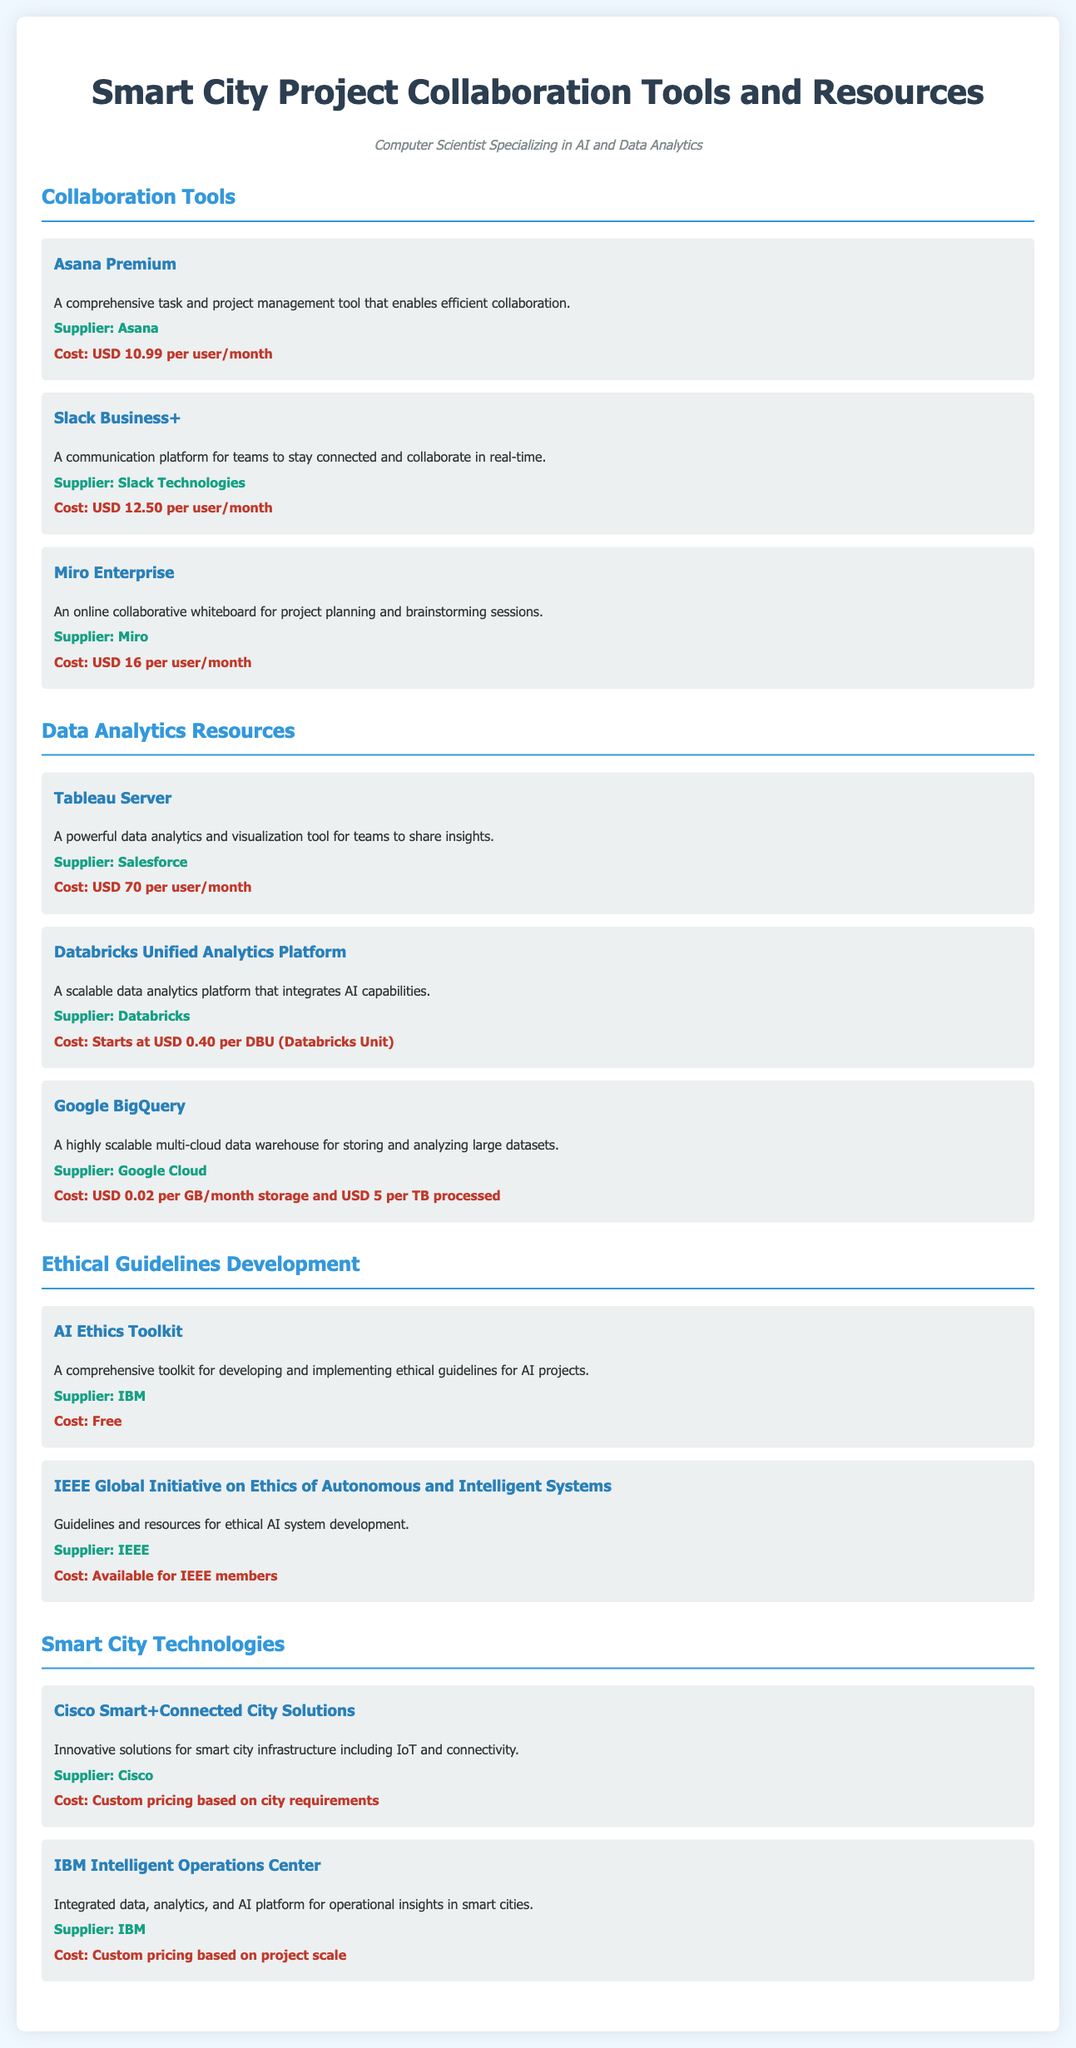What is the cost of Asana Premium? The cost of Asana Premium is USD 10.99 per user/month as stated in the collaboration tools section.
Answer: USD 10.99 per user/month Who is the supplier for Google BigQuery? The supplier for Google BigQuery mentioned in the document is Google Cloud.
Answer: Google Cloud What type of collaboration tool is Miro Enterprise? Miro Enterprise is described as an online collaborative whiteboard for project planning and brainstorming sessions.
Answer: Online collaborative whiteboard What is the cost of the AI Ethics Toolkit? According to the ethical guidelines development section, the AI Ethics Toolkit is free of charge.
Answer: Free How much does Tableau Server cost per user? Tableau Server costs USD 70 per user/month as listed in the data analytics resources section.
Answer: USD 70 per user/month Which company provides the Cisco Smart+Connected City Solutions? Cisco is the supplier of the Smart+Connected City Solutions as stated in the smart city technologies section.
Answer: Cisco What customization does the IBM Intelligent Operations Center pricing depend on? The pricing for the IBM Intelligent Operations Center is based on project scale as mentioned in the smart city technologies section.
Answer: Project scale What is available for IEEE members regarding ethical AI resources? The guidelines and resources for ethical AI system development are available for IEEE members, according to the ethical guidelines development section.
Answer: Available for IEEE members 